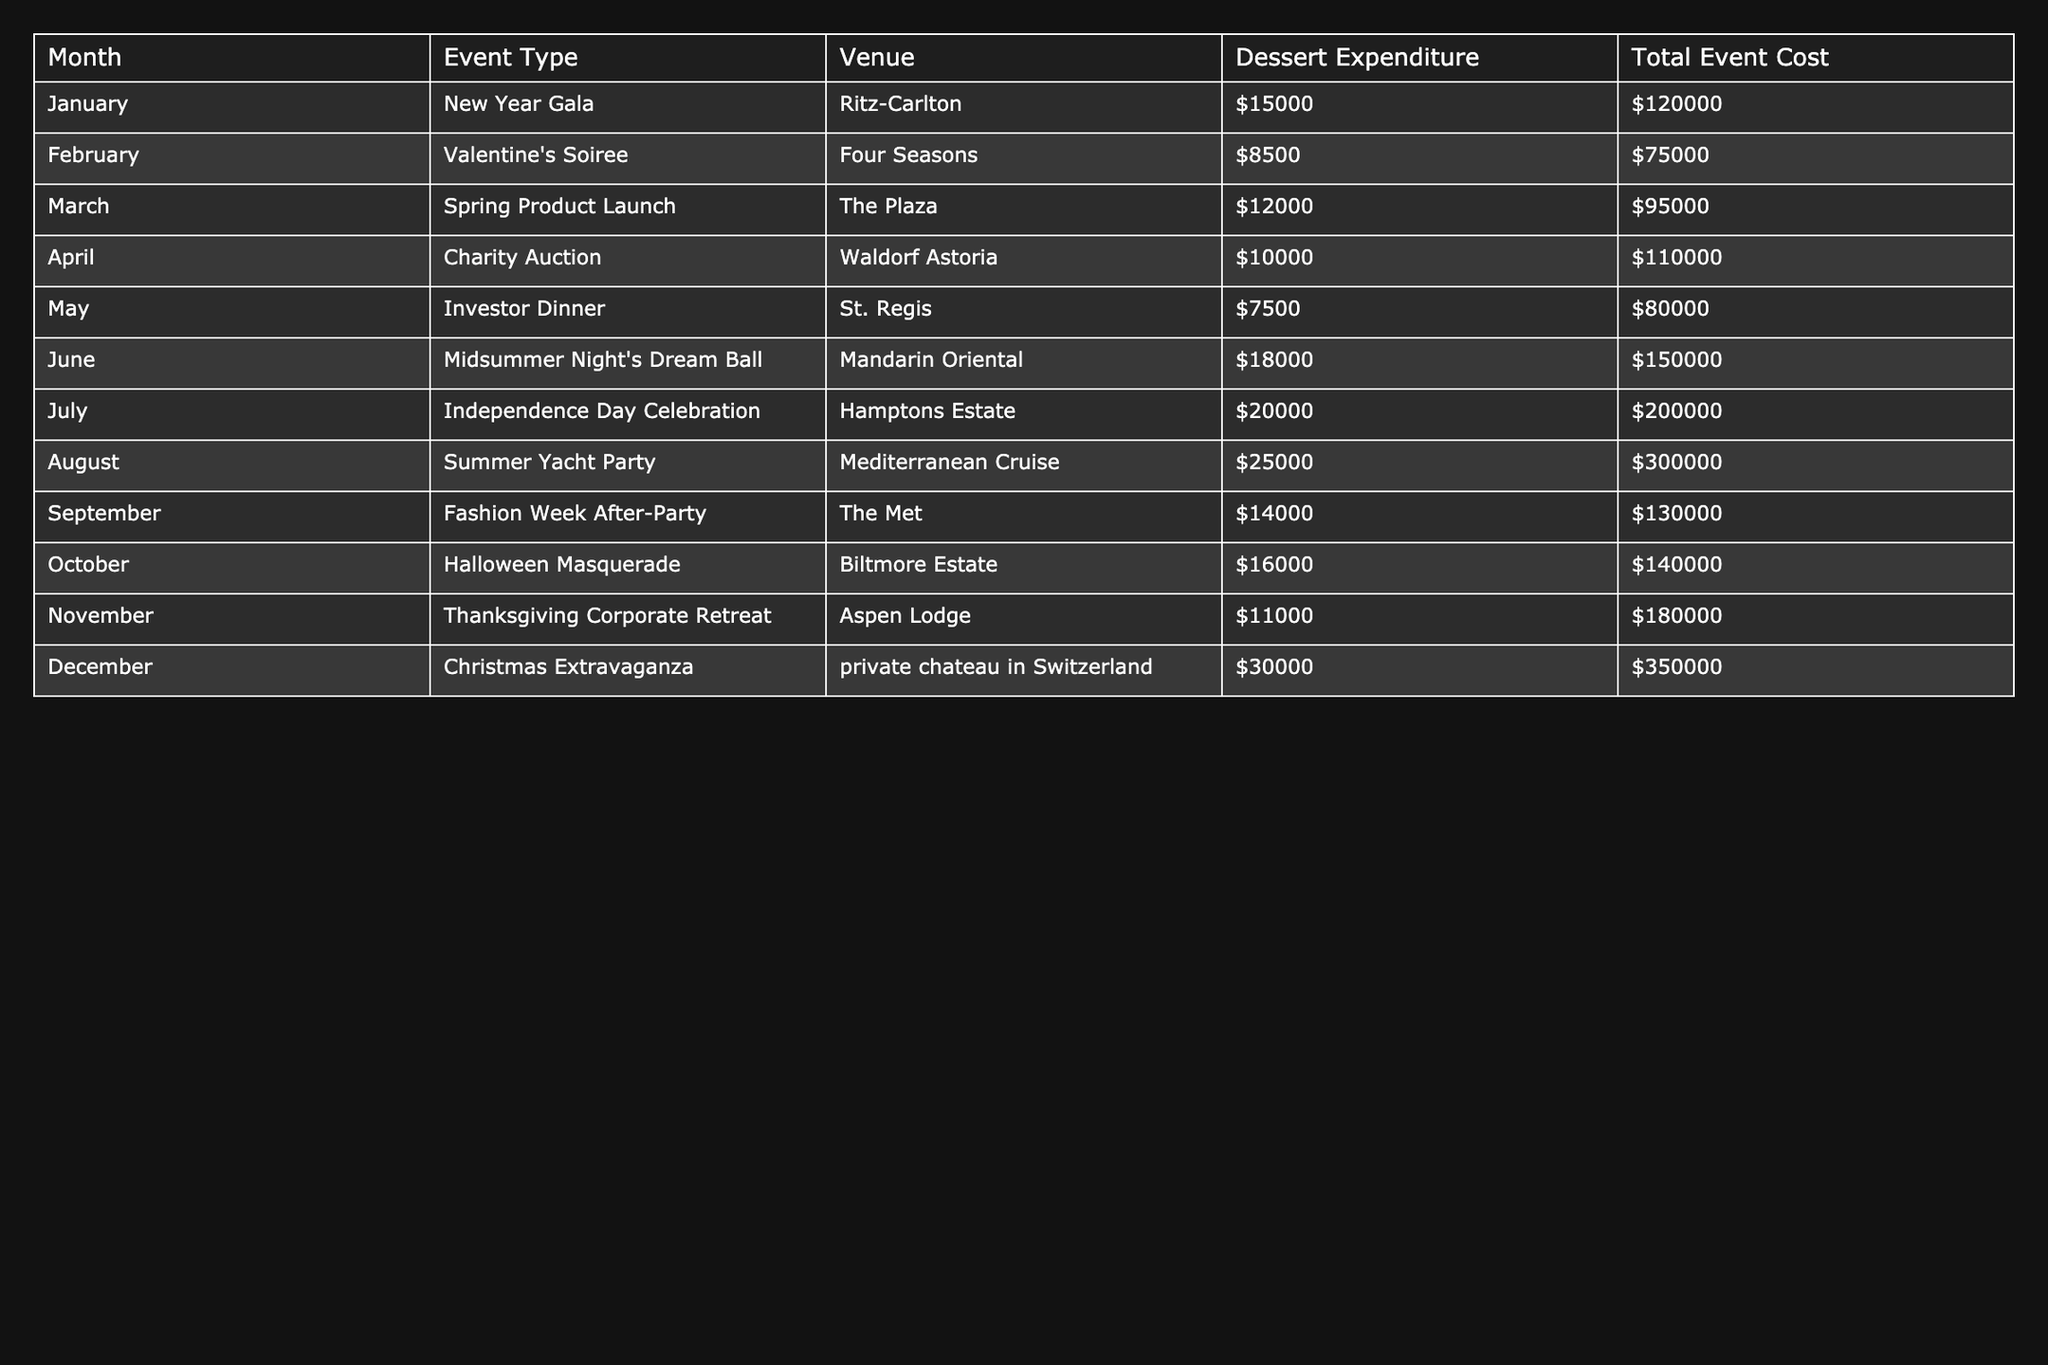What is the total dessert expenditure for June? To find the total dessert expenditure for June, look at the specific row for June in the "Dessert Expenditure" column, which shows $18,000.
Answer: $18,000 Which month has the highest total event cost? By examining the "Total Event Cost" column, the maximum value can be identified as $350,000 in December.
Answer: December How much did the Independence Day Celebration cost compared to the Charity Auction? The cost of the Independence Day Celebration is $200,000 and the Charity Auction is $110,000. Thus, the difference is $200,000 - $110,000 = $90,000.
Answer: $90,000 Did any events have dessert expenditures of less than $10,000? By reviewing the "Dessert Expenditure" column, we see that the events in February ($8,500) and May ($7,500) have dessert expenditures below $10,000, confirming that yes, such events exist.
Answer: Yes What is the average dessert expenditure for the events in the first half of the year (January to June)? The dessert expenditures for the first half are $15,000 (January), $8,500 (February), $12,000 (March), $10,000 (April), $7,500 (May), and $18,000 (June). Their sum is $71,000. There are 6 months, so the average is $71,000 / 6 = $11,833.33, hence rounded to $11,833.
Answer: $11,833 Which event had the lowest dessert expenditure, and what was that amount? By inspecting the "Dessert Expenditure" column, the lowest amount is $7,500 attributed to the Investor Dinner in May.
Answer: $7,500 How much more did the Christmas Extravaganza dessert costs compared to Valentine's Soiree? The dessert cost for Christmas Extravaganza is $30,000 and for Valentine's Soiree is $8,500. The difference is calculated as $30,000 - $8,500 = $21,500.
Answer: $21,500 How many events had a total event cost that exceeded $150,000? By counting the rows where the "Total Event Cost" exceeds $150,000, we see these events: June ($150,000), July ($200,000), August ($300,000), October ($140,000), November ($180,000), and December ($350,000). There are 4 events that meet this criterion.
Answer: 4 